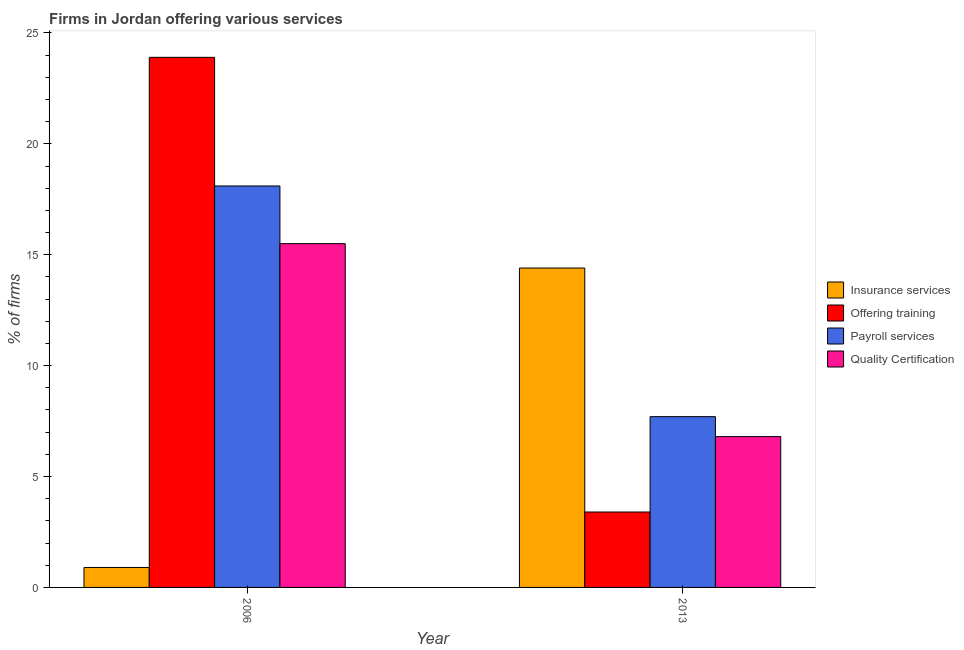How many groups of bars are there?
Keep it short and to the point. 2. Are the number of bars on each tick of the X-axis equal?
Provide a short and direct response. Yes. How many bars are there on the 1st tick from the left?
Your response must be concise. 4. How many bars are there on the 1st tick from the right?
Offer a terse response. 4. What is the label of the 2nd group of bars from the left?
Your answer should be compact. 2013. Across all years, what is the maximum percentage of firms offering quality certification?
Make the answer very short. 15.5. Across all years, what is the minimum percentage of firms offering training?
Ensure brevity in your answer.  3.4. In which year was the percentage of firms offering payroll services minimum?
Your answer should be compact. 2013. What is the total percentage of firms offering quality certification in the graph?
Provide a short and direct response. 22.3. What is the difference between the percentage of firms offering insurance services in 2006 and that in 2013?
Offer a terse response. -13.5. What is the difference between the percentage of firms offering payroll services in 2013 and the percentage of firms offering training in 2006?
Your answer should be compact. -10.4. What is the average percentage of firms offering insurance services per year?
Ensure brevity in your answer.  7.65. In the year 2006, what is the difference between the percentage of firms offering quality certification and percentage of firms offering payroll services?
Make the answer very short. 0. What is the ratio of the percentage of firms offering payroll services in 2006 to that in 2013?
Your answer should be very brief. 2.35. In how many years, is the percentage of firms offering insurance services greater than the average percentage of firms offering insurance services taken over all years?
Give a very brief answer. 1. Is it the case that in every year, the sum of the percentage of firms offering training and percentage of firms offering payroll services is greater than the sum of percentage of firms offering insurance services and percentage of firms offering quality certification?
Your answer should be compact. No. What does the 2nd bar from the left in 2006 represents?
Your answer should be compact. Offering training. What does the 1st bar from the right in 2013 represents?
Provide a succinct answer. Quality Certification. How many bars are there?
Your response must be concise. 8. Are all the bars in the graph horizontal?
Give a very brief answer. No. How many years are there in the graph?
Your answer should be very brief. 2. Does the graph contain grids?
Ensure brevity in your answer.  No. What is the title of the graph?
Keep it short and to the point. Firms in Jordan offering various services . Does "Macroeconomic management" appear as one of the legend labels in the graph?
Your answer should be compact. No. What is the label or title of the X-axis?
Make the answer very short. Year. What is the label or title of the Y-axis?
Your answer should be very brief. % of firms. What is the % of firms in Offering training in 2006?
Your response must be concise. 23.9. What is the % of firms in Payroll services in 2006?
Keep it short and to the point. 18.1. What is the % of firms in Insurance services in 2013?
Keep it short and to the point. 14.4. What is the % of firms of Offering training in 2013?
Your answer should be very brief. 3.4. What is the % of firms of Payroll services in 2013?
Give a very brief answer. 7.7. Across all years, what is the maximum % of firms of Offering training?
Keep it short and to the point. 23.9. Across all years, what is the maximum % of firms in Payroll services?
Offer a terse response. 18.1. Across all years, what is the maximum % of firms of Quality Certification?
Provide a short and direct response. 15.5. Across all years, what is the minimum % of firms of Payroll services?
Ensure brevity in your answer.  7.7. Across all years, what is the minimum % of firms in Quality Certification?
Give a very brief answer. 6.8. What is the total % of firms in Offering training in the graph?
Give a very brief answer. 27.3. What is the total % of firms in Payroll services in the graph?
Ensure brevity in your answer.  25.8. What is the total % of firms in Quality Certification in the graph?
Your response must be concise. 22.3. What is the difference between the % of firms of Insurance services in 2006 and that in 2013?
Your answer should be compact. -13.5. What is the difference between the % of firms of Offering training in 2006 and that in 2013?
Your answer should be very brief. 20.5. What is the difference between the % of firms of Payroll services in 2006 and that in 2013?
Provide a succinct answer. 10.4. What is the difference between the % of firms in Insurance services in 2006 and the % of firms in Payroll services in 2013?
Your answer should be compact. -6.8. What is the difference between the % of firms of Offering training in 2006 and the % of firms of Payroll services in 2013?
Keep it short and to the point. 16.2. What is the difference between the % of firms of Payroll services in 2006 and the % of firms of Quality Certification in 2013?
Ensure brevity in your answer.  11.3. What is the average % of firms of Insurance services per year?
Keep it short and to the point. 7.65. What is the average % of firms of Offering training per year?
Offer a terse response. 13.65. What is the average % of firms of Payroll services per year?
Offer a terse response. 12.9. What is the average % of firms of Quality Certification per year?
Give a very brief answer. 11.15. In the year 2006, what is the difference between the % of firms of Insurance services and % of firms of Payroll services?
Offer a terse response. -17.2. In the year 2006, what is the difference between the % of firms in Insurance services and % of firms in Quality Certification?
Offer a very short reply. -14.6. In the year 2006, what is the difference between the % of firms of Offering training and % of firms of Payroll services?
Give a very brief answer. 5.8. In the year 2006, what is the difference between the % of firms of Offering training and % of firms of Quality Certification?
Provide a succinct answer. 8.4. In the year 2013, what is the difference between the % of firms in Insurance services and % of firms in Offering training?
Your response must be concise. 11. In the year 2013, what is the difference between the % of firms of Offering training and % of firms of Quality Certification?
Give a very brief answer. -3.4. What is the ratio of the % of firms in Insurance services in 2006 to that in 2013?
Your answer should be very brief. 0.06. What is the ratio of the % of firms of Offering training in 2006 to that in 2013?
Ensure brevity in your answer.  7.03. What is the ratio of the % of firms in Payroll services in 2006 to that in 2013?
Offer a very short reply. 2.35. What is the ratio of the % of firms in Quality Certification in 2006 to that in 2013?
Provide a succinct answer. 2.28. What is the difference between the highest and the second highest % of firms in Insurance services?
Ensure brevity in your answer.  13.5. What is the difference between the highest and the second highest % of firms in Offering training?
Your answer should be very brief. 20.5. What is the difference between the highest and the second highest % of firms of Payroll services?
Your response must be concise. 10.4. What is the difference between the highest and the second highest % of firms in Quality Certification?
Make the answer very short. 8.7. What is the difference between the highest and the lowest % of firms in Insurance services?
Your answer should be compact. 13.5. What is the difference between the highest and the lowest % of firms of Quality Certification?
Your response must be concise. 8.7. 